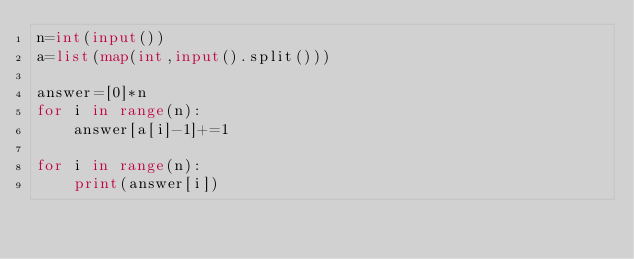<code> <loc_0><loc_0><loc_500><loc_500><_Python_>n=int(input())
a=list(map(int,input().split()))

answer=[0]*n
for i in range(n):
    answer[a[i]-1]+=1

for i in range(n):
    print(answer[i])

</code> 